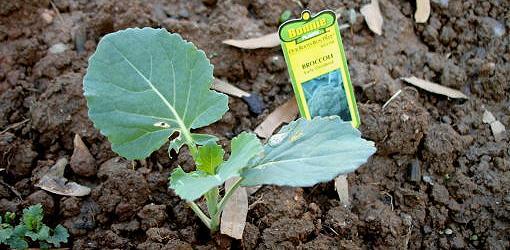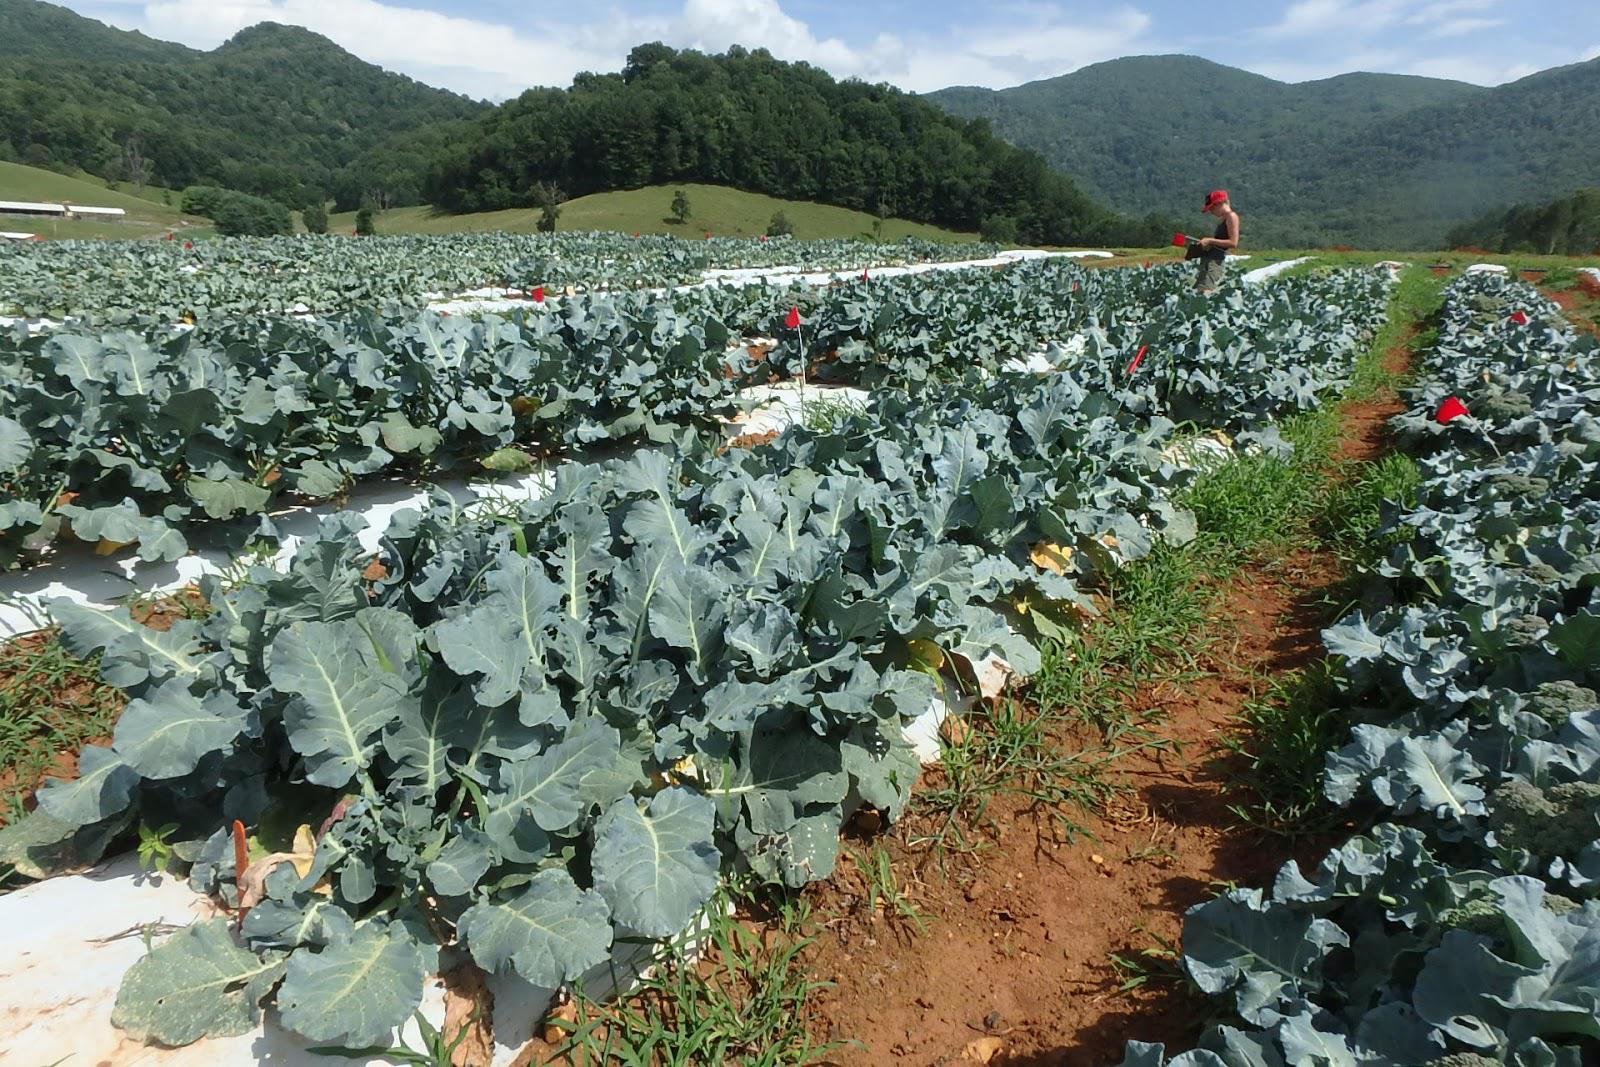The first image is the image on the left, the second image is the image on the right. For the images displayed, is the sentence "All images show broccoli in a round container of some type." factually correct? Answer yes or no. No. The first image is the image on the left, the second image is the image on the right. Assess this claim about the two images: "There is a human head in the image on the right.". Correct or not? Answer yes or no. Yes. 